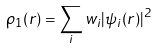<formula> <loc_0><loc_0><loc_500><loc_500>\rho _ { 1 } ( { r } ) = \sum _ { i } w _ { i } | \psi _ { i } ( { r } ) | ^ { 2 }</formula> 